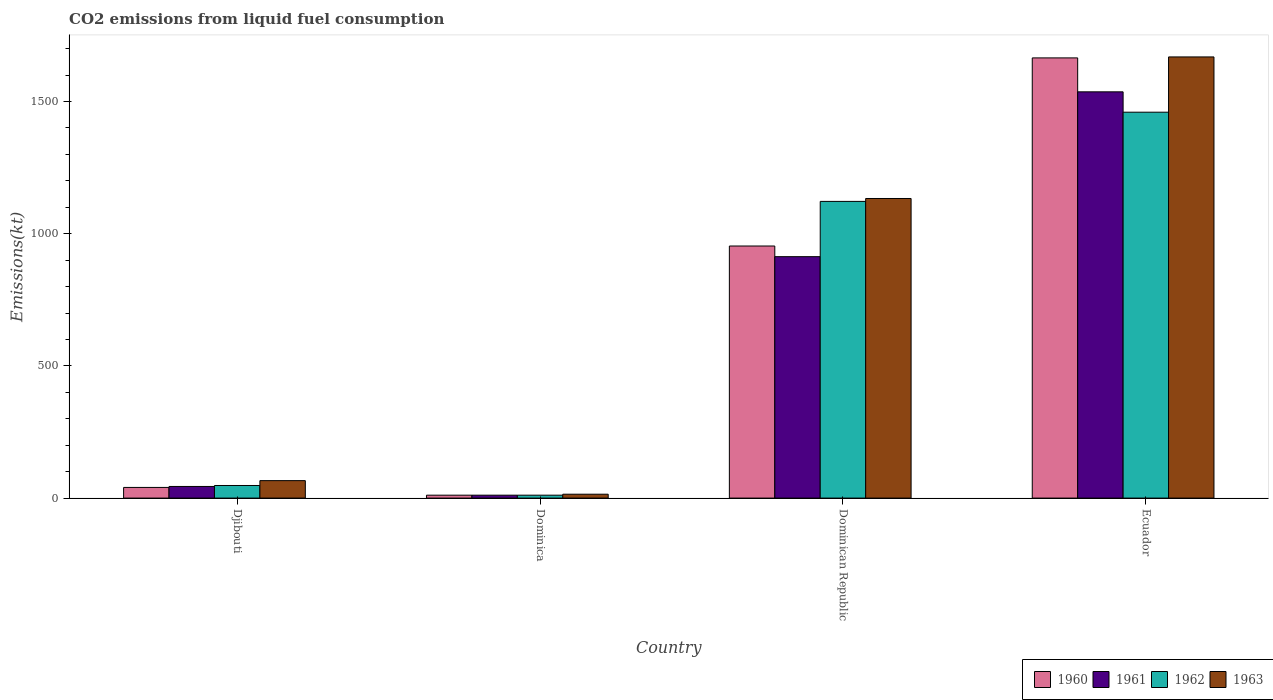How many groups of bars are there?
Give a very brief answer. 4. Are the number of bars on each tick of the X-axis equal?
Your response must be concise. Yes. What is the label of the 4th group of bars from the left?
Offer a terse response. Ecuador. What is the amount of CO2 emitted in 1963 in Dominican Republic?
Offer a very short reply. 1133.1. Across all countries, what is the maximum amount of CO2 emitted in 1961?
Ensure brevity in your answer.  1536.47. Across all countries, what is the minimum amount of CO2 emitted in 1960?
Give a very brief answer. 11. In which country was the amount of CO2 emitted in 1962 maximum?
Offer a terse response. Ecuador. In which country was the amount of CO2 emitted in 1963 minimum?
Provide a succinct answer. Dominica. What is the total amount of CO2 emitted in 1961 in the graph?
Your answer should be compact. 2504.56. What is the difference between the amount of CO2 emitted in 1960 in Djibouti and that in Dominica?
Your response must be concise. 29.34. What is the difference between the amount of CO2 emitted in 1963 in Dominican Republic and the amount of CO2 emitted in 1961 in Dominica?
Provide a short and direct response. 1122.1. What is the average amount of CO2 emitted in 1961 per country?
Provide a succinct answer. 626.14. What is the ratio of the amount of CO2 emitted in 1960 in Dominica to that in Ecuador?
Provide a succinct answer. 0.01. Is the amount of CO2 emitted in 1962 in Djibouti less than that in Dominica?
Ensure brevity in your answer.  No. What is the difference between the highest and the second highest amount of CO2 emitted in 1960?
Your answer should be compact. 711.4. What is the difference between the highest and the lowest amount of CO2 emitted in 1962?
Make the answer very short. 1448.46. In how many countries, is the amount of CO2 emitted in 1962 greater than the average amount of CO2 emitted in 1962 taken over all countries?
Your answer should be very brief. 2. Is it the case that in every country, the sum of the amount of CO2 emitted in 1962 and amount of CO2 emitted in 1963 is greater than the sum of amount of CO2 emitted in 1960 and amount of CO2 emitted in 1961?
Your answer should be very brief. No. What does the 1st bar from the right in Dominican Republic represents?
Offer a very short reply. 1963. Is it the case that in every country, the sum of the amount of CO2 emitted in 1961 and amount of CO2 emitted in 1962 is greater than the amount of CO2 emitted in 1963?
Offer a terse response. Yes. How many countries are there in the graph?
Your response must be concise. 4. Does the graph contain any zero values?
Ensure brevity in your answer.  No. Does the graph contain grids?
Keep it short and to the point. No. What is the title of the graph?
Your response must be concise. CO2 emissions from liquid fuel consumption. Does "1972" appear as one of the legend labels in the graph?
Provide a succinct answer. No. What is the label or title of the X-axis?
Keep it short and to the point. Country. What is the label or title of the Y-axis?
Offer a very short reply. Emissions(kt). What is the Emissions(kt) in 1960 in Djibouti?
Give a very brief answer. 40.34. What is the Emissions(kt) in 1961 in Djibouti?
Your response must be concise. 44. What is the Emissions(kt) in 1962 in Djibouti?
Offer a very short reply. 47.67. What is the Emissions(kt) in 1963 in Djibouti?
Your answer should be compact. 66.01. What is the Emissions(kt) in 1960 in Dominica?
Keep it short and to the point. 11. What is the Emissions(kt) in 1961 in Dominica?
Offer a terse response. 11. What is the Emissions(kt) of 1962 in Dominica?
Offer a very short reply. 11. What is the Emissions(kt) of 1963 in Dominica?
Provide a short and direct response. 14.67. What is the Emissions(kt) in 1960 in Dominican Republic?
Your answer should be very brief. 953.42. What is the Emissions(kt) in 1961 in Dominican Republic?
Give a very brief answer. 913.08. What is the Emissions(kt) of 1962 in Dominican Republic?
Your answer should be very brief. 1122.1. What is the Emissions(kt) in 1963 in Dominican Republic?
Provide a succinct answer. 1133.1. What is the Emissions(kt) in 1960 in Ecuador?
Keep it short and to the point. 1664.82. What is the Emissions(kt) in 1961 in Ecuador?
Your response must be concise. 1536.47. What is the Emissions(kt) in 1962 in Ecuador?
Your response must be concise. 1459.47. What is the Emissions(kt) in 1963 in Ecuador?
Your answer should be very brief. 1668.48. Across all countries, what is the maximum Emissions(kt) of 1960?
Your answer should be compact. 1664.82. Across all countries, what is the maximum Emissions(kt) in 1961?
Give a very brief answer. 1536.47. Across all countries, what is the maximum Emissions(kt) of 1962?
Make the answer very short. 1459.47. Across all countries, what is the maximum Emissions(kt) in 1963?
Make the answer very short. 1668.48. Across all countries, what is the minimum Emissions(kt) of 1960?
Your response must be concise. 11. Across all countries, what is the minimum Emissions(kt) in 1961?
Your response must be concise. 11. Across all countries, what is the minimum Emissions(kt) of 1962?
Give a very brief answer. 11. Across all countries, what is the minimum Emissions(kt) in 1963?
Make the answer very short. 14.67. What is the total Emissions(kt) of 1960 in the graph?
Keep it short and to the point. 2669.58. What is the total Emissions(kt) in 1961 in the graph?
Give a very brief answer. 2504.56. What is the total Emissions(kt) in 1962 in the graph?
Ensure brevity in your answer.  2640.24. What is the total Emissions(kt) of 1963 in the graph?
Keep it short and to the point. 2882.26. What is the difference between the Emissions(kt) of 1960 in Djibouti and that in Dominica?
Provide a short and direct response. 29.34. What is the difference between the Emissions(kt) of 1961 in Djibouti and that in Dominica?
Your answer should be compact. 33. What is the difference between the Emissions(kt) in 1962 in Djibouti and that in Dominica?
Offer a very short reply. 36.67. What is the difference between the Emissions(kt) of 1963 in Djibouti and that in Dominica?
Your response must be concise. 51.34. What is the difference between the Emissions(kt) in 1960 in Djibouti and that in Dominican Republic?
Ensure brevity in your answer.  -913.08. What is the difference between the Emissions(kt) in 1961 in Djibouti and that in Dominican Republic?
Make the answer very short. -869.08. What is the difference between the Emissions(kt) in 1962 in Djibouti and that in Dominican Republic?
Give a very brief answer. -1074.43. What is the difference between the Emissions(kt) in 1963 in Djibouti and that in Dominican Republic?
Provide a succinct answer. -1067.1. What is the difference between the Emissions(kt) of 1960 in Djibouti and that in Ecuador?
Your answer should be very brief. -1624.48. What is the difference between the Emissions(kt) of 1961 in Djibouti and that in Ecuador?
Your answer should be compact. -1492.47. What is the difference between the Emissions(kt) in 1962 in Djibouti and that in Ecuador?
Keep it short and to the point. -1411.8. What is the difference between the Emissions(kt) in 1963 in Djibouti and that in Ecuador?
Your response must be concise. -1602.48. What is the difference between the Emissions(kt) of 1960 in Dominica and that in Dominican Republic?
Keep it short and to the point. -942.42. What is the difference between the Emissions(kt) of 1961 in Dominica and that in Dominican Republic?
Your answer should be very brief. -902.08. What is the difference between the Emissions(kt) of 1962 in Dominica and that in Dominican Republic?
Your answer should be very brief. -1111.1. What is the difference between the Emissions(kt) of 1963 in Dominica and that in Dominican Republic?
Offer a very short reply. -1118.43. What is the difference between the Emissions(kt) in 1960 in Dominica and that in Ecuador?
Offer a terse response. -1653.82. What is the difference between the Emissions(kt) in 1961 in Dominica and that in Ecuador?
Your answer should be compact. -1525.47. What is the difference between the Emissions(kt) in 1962 in Dominica and that in Ecuador?
Ensure brevity in your answer.  -1448.46. What is the difference between the Emissions(kt) of 1963 in Dominica and that in Ecuador?
Give a very brief answer. -1653.82. What is the difference between the Emissions(kt) of 1960 in Dominican Republic and that in Ecuador?
Ensure brevity in your answer.  -711.4. What is the difference between the Emissions(kt) of 1961 in Dominican Republic and that in Ecuador?
Your response must be concise. -623.39. What is the difference between the Emissions(kt) in 1962 in Dominican Republic and that in Ecuador?
Provide a short and direct response. -337.36. What is the difference between the Emissions(kt) of 1963 in Dominican Republic and that in Ecuador?
Keep it short and to the point. -535.38. What is the difference between the Emissions(kt) in 1960 in Djibouti and the Emissions(kt) in 1961 in Dominica?
Provide a short and direct response. 29.34. What is the difference between the Emissions(kt) of 1960 in Djibouti and the Emissions(kt) of 1962 in Dominica?
Provide a succinct answer. 29.34. What is the difference between the Emissions(kt) of 1960 in Djibouti and the Emissions(kt) of 1963 in Dominica?
Your answer should be very brief. 25.67. What is the difference between the Emissions(kt) in 1961 in Djibouti and the Emissions(kt) in 1962 in Dominica?
Make the answer very short. 33. What is the difference between the Emissions(kt) in 1961 in Djibouti and the Emissions(kt) in 1963 in Dominica?
Your answer should be very brief. 29.34. What is the difference between the Emissions(kt) in 1962 in Djibouti and the Emissions(kt) in 1963 in Dominica?
Keep it short and to the point. 33. What is the difference between the Emissions(kt) in 1960 in Djibouti and the Emissions(kt) in 1961 in Dominican Republic?
Ensure brevity in your answer.  -872.75. What is the difference between the Emissions(kt) of 1960 in Djibouti and the Emissions(kt) of 1962 in Dominican Republic?
Your answer should be compact. -1081.77. What is the difference between the Emissions(kt) of 1960 in Djibouti and the Emissions(kt) of 1963 in Dominican Republic?
Provide a succinct answer. -1092.77. What is the difference between the Emissions(kt) in 1961 in Djibouti and the Emissions(kt) in 1962 in Dominican Republic?
Your response must be concise. -1078.1. What is the difference between the Emissions(kt) in 1961 in Djibouti and the Emissions(kt) in 1963 in Dominican Republic?
Ensure brevity in your answer.  -1089.1. What is the difference between the Emissions(kt) of 1962 in Djibouti and the Emissions(kt) of 1963 in Dominican Republic?
Make the answer very short. -1085.43. What is the difference between the Emissions(kt) of 1960 in Djibouti and the Emissions(kt) of 1961 in Ecuador?
Your response must be concise. -1496.14. What is the difference between the Emissions(kt) in 1960 in Djibouti and the Emissions(kt) in 1962 in Ecuador?
Ensure brevity in your answer.  -1419.13. What is the difference between the Emissions(kt) of 1960 in Djibouti and the Emissions(kt) of 1963 in Ecuador?
Offer a very short reply. -1628.15. What is the difference between the Emissions(kt) of 1961 in Djibouti and the Emissions(kt) of 1962 in Ecuador?
Your response must be concise. -1415.46. What is the difference between the Emissions(kt) of 1961 in Djibouti and the Emissions(kt) of 1963 in Ecuador?
Your answer should be very brief. -1624.48. What is the difference between the Emissions(kt) in 1962 in Djibouti and the Emissions(kt) in 1963 in Ecuador?
Your answer should be compact. -1620.81. What is the difference between the Emissions(kt) in 1960 in Dominica and the Emissions(kt) in 1961 in Dominican Republic?
Give a very brief answer. -902.08. What is the difference between the Emissions(kt) in 1960 in Dominica and the Emissions(kt) in 1962 in Dominican Republic?
Give a very brief answer. -1111.1. What is the difference between the Emissions(kt) in 1960 in Dominica and the Emissions(kt) in 1963 in Dominican Republic?
Offer a very short reply. -1122.1. What is the difference between the Emissions(kt) of 1961 in Dominica and the Emissions(kt) of 1962 in Dominican Republic?
Make the answer very short. -1111.1. What is the difference between the Emissions(kt) of 1961 in Dominica and the Emissions(kt) of 1963 in Dominican Republic?
Provide a succinct answer. -1122.1. What is the difference between the Emissions(kt) of 1962 in Dominica and the Emissions(kt) of 1963 in Dominican Republic?
Offer a very short reply. -1122.1. What is the difference between the Emissions(kt) of 1960 in Dominica and the Emissions(kt) of 1961 in Ecuador?
Provide a short and direct response. -1525.47. What is the difference between the Emissions(kt) in 1960 in Dominica and the Emissions(kt) in 1962 in Ecuador?
Ensure brevity in your answer.  -1448.46. What is the difference between the Emissions(kt) of 1960 in Dominica and the Emissions(kt) of 1963 in Ecuador?
Your answer should be very brief. -1657.48. What is the difference between the Emissions(kt) of 1961 in Dominica and the Emissions(kt) of 1962 in Ecuador?
Provide a succinct answer. -1448.46. What is the difference between the Emissions(kt) of 1961 in Dominica and the Emissions(kt) of 1963 in Ecuador?
Offer a terse response. -1657.48. What is the difference between the Emissions(kt) in 1962 in Dominica and the Emissions(kt) in 1963 in Ecuador?
Make the answer very short. -1657.48. What is the difference between the Emissions(kt) in 1960 in Dominican Republic and the Emissions(kt) in 1961 in Ecuador?
Provide a short and direct response. -583.05. What is the difference between the Emissions(kt) in 1960 in Dominican Republic and the Emissions(kt) in 1962 in Ecuador?
Your answer should be very brief. -506.05. What is the difference between the Emissions(kt) of 1960 in Dominican Republic and the Emissions(kt) of 1963 in Ecuador?
Make the answer very short. -715.07. What is the difference between the Emissions(kt) of 1961 in Dominican Republic and the Emissions(kt) of 1962 in Ecuador?
Give a very brief answer. -546.38. What is the difference between the Emissions(kt) of 1961 in Dominican Republic and the Emissions(kt) of 1963 in Ecuador?
Make the answer very short. -755.4. What is the difference between the Emissions(kt) in 1962 in Dominican Republic and the Emissions(kt) in 1963 in Ecuador?
Your answer should be very brief. -546.38. What is the average Emissions(kt) in 1960 per country?
Give a very brief answer. 667.39. What is the average Emissions(kt) of 1961 per country?
Provide a succinct answer. 626.14. What is the average Emissions(kt) of 1962 per country?
Keep it short and to the point. 660.06. What is the average Emissions(kt) in 1963 per country?
Your answer should be very brief. 720.57. What is the difference between the Emissions(kt) in 1960 and Emissions(kt) in 1961 in Djibouti?
Your answer should be very brief. -3.67. What is the difference between the Emissions(kt) of 1960 and Emissions(kt) of 1962 in Djibouti?
Offer a terse response. -7.33. What is the difference between the Emissions(kt) of 1960 and Emissions(kt) of 1963 in Djibouti?
Ensure brevity in your answer.  -25.67. What is the difference between the Emissions(kt) of 1961 and Emissions(kt) of 1962 in Djibouti?
Ensure brevity in your answer.  -3.67. What is the difference between the Emissions(kt) of 1961 and Emissions(kt) of 1963 in Djibouti?
Offer a terse response. -22. What is the difference between the Emissions(kt) of 1962 and Emissions(kt) of 1963 in Djibouti?
Provide a short and direct response. -18.34. What is the difference between the Emissions(kt) in 1960 and Emissions(kt) in 1961 in Dominica?
Your answer should be compact. 0. What is the difference between the Emissions(kt) of 1960 and Emissions(kt) of 1963 in Dominica?
Provide a succinct answer. -3.67. What is the difference between the Emissions(kt) of 1961 and Emissions(kt) of 1962 in Dominica?
Keep it short and to the point. 0. What is the difference between the Emissions(kt) in 1961 and Emissions(kt) in 1963 in Dominica?
Keep it short and to the point. -3.67. What is the difference between the Emissions(kt) of 1962 and Emissions(kt) of 1963 in Dominica?
Your response must be concise. -3.67. What is the difference between the Emissions(kt) of 1960 and Emissions(kt) of 1961 in Dominican Republic?
Ensure brevity in your answer.  40.34. What is the difference between the Emissions(kt) in 1960 and Emissions(kt) in 1962 in Dominican Republic?
Make the answer very short. -168.68. What is the difference between the Emissions(kt) of 1960 and Emissions(kt) of 1963 in Dominican Republic?
Make the answer very short. -179.68. What is the difference between the Emissions(kt) in 1961 and Emissions(kt) in 1962 in Dominican Republic?
Give a very brief answer. -209.02. What is the difference between the Emissions(kt) in 1961 and Emissions(kt) in 1963 in Dominican Republic?
Make the answer very short. -220.02. What is the difference between the Emissions(kt) in 1962 and Emissions(kt) in 1963 in Dominican Republic?
Your response must be concise. -11. What is the difference between the Emissions(kt) in 1960 and Emissions(kt) in 1961 in Ecuador?
Your answer should be very brief. 128.34. What is the difference between the Emissions(kt) in 1960 and Emissions(kt) in 1962 in Ecuador?
Give a very brief answer. 205.35. What is the difference between the Emissions(kt) of 1960 and Emissions(kt) of 1963 in Ecuador?
Provide a succinct answer. -3.67. What is the difference between the Emissions(kt) of 1961 and Emissions(kt) of 1962 in Ecuador?
Ensure brevity in your answer.  77.01. What is the difference between the Emissions(kt) of 1961 and Emissions(kt) of 1963 in Ecuador?
Keep it short and to the point. -132.01. What is the difference between the Emissions(kt) of 1962 and Emissions(kt) of 1963 in Ecuador?
Your response must be concise. -209.02. What is the ratio of the Emissions(kt) of 1960 in Djibouti to that in Dominica?
Offer a very short reply. 3.67. What is the ratio of the Emissions(kt) in 1961 in Djibouti to that in Dominica?
Give a very brief answer. 4. What is the ratio of the Emissions(kt) in 1962 in Djibouti to that in Dominica?
Provide a succinct answer. 4.33. What is the ratio of the Emissions(kt) of 1960 in Djibouti to that in Dominican Republic?
Your answer should be compact. 0.04. What is the ratio of the Emissions(kt) in 1961 in Djibouti to that in Dominican Republic?
Provide a succinct answer. 0.05. What is the ratio of the Emissions(kt) in 1962 in Djibouti to that in Dominican Republic?
Give a very brief answer. 0.04. What is the ratio of the Emissions(kt) in 1963 in Djibouti to that in Dominican Republic?
Offer a terse response. 0.06. What is the ratio of the Emissions(kt) in 1960 in Djibouti to that in Ecuador?
Provide a short and direct response. 0.02. What is the ratio of the Emissions(kt) in 1961 in Djibouti to that in Ecuador?
Keep it short and to the point. 0.03. What is the ratio of the Emissions(kt) of 1962 in Djibouti to that in Ecuador?
Provide a succinct answer. 0.03. What is the ratio of the Emissions(kt) of 1963 in Djibouti to that in Ecuador?
Give a very brief answer. 0.04. What is the ratio of the Emissions(kt) in 1960 in Dominica to that in Dominican Republic?
Offer a very short reply. 0.01. What is the ratio of the Emissions(kt) of 1961 in Dominica to that in Dominican Republic?
Offer a very short reply. 0.01. What is the ratio of the Emissions(kt) of 1962 in Dominica to that in Dominican Republic?
Your answer should be compact. 0.01. What is the ratio of the Emissions(kt) of 1963 in Dominica to that in Dominican Republic?
Offer a very short reply. 0.01. What is the ratio of the Emissions(kt) in 1960 in Dominica to that in Ecuador?
Your answer should be compact. 0.01. What is the ratio of the Emissions(kt) of 1961 in Dominica to that in Ecuador?
Provide a short and direct response. 0.01. What is the ratio of the Emissions(kt) in 1962 in Dominica to that in Ecuador?
Ensure brevity in your answer.  0.01. What is the ratio of the Emissions(kt) of 1963 in Dominica to that in Ecuador?
Give a very brief answer. 0.01. What is the ratio of the Emissions(kt) of 1960 in Dominican Republic to that in Ecuador?
Make the answer very short. 0.57. What is the ratio of the Emissions(kt) in 1961 in Dominican Republic to that in Ecuador?
Offer a very short reply. 0.59. What is the ratio of the Emissions(kt) in 1962 in Dominican Republic to that in Ecuador?
Ensure brevity in your answer.  0.77. What is the ratio of the Emissions(kt) of 1963 in Dominican Republic to that in Ecuador?
Your answer should be very brief. 0.68. What is the difference between the highest and the second highest Emissions(kt) of 1960?
Make the answer very short. 711.4. What is the difference between the highest and the second highest Emissions(kt) of 1961?
Provide a short and direct response. 623.39. What is the difference between the highest and the second highest Emissions(kt) of 1962?
Keep it short and to the point. 337.36. What is the difference between the highest and the second highest Emissions(kt) in 1963?
Give a very brief answer. 535.38. What is the difference between the highest and the lowest Emissions(kt) in 1960?
Provide a succinct answer. 1653.82. What is the difference between the highest and the lowest Emissions(kt) of 1961?
Offer a very short reply. 1525.47. What is the difference between the highest and the lowest Emissions(kt) in 1962?
Make the answer very short. 1448.46. What is the difference between the highest and the lowest Emissions(kt) in 1963?
Give a very brief answer. 1653.82. 